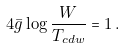Convert formula to latex. <formula><loc_0><loc_0><loc_500><loc_500>4 \bar { g } \log \frac { W } { T _ { c d w } } = 1 \, .</formula> 